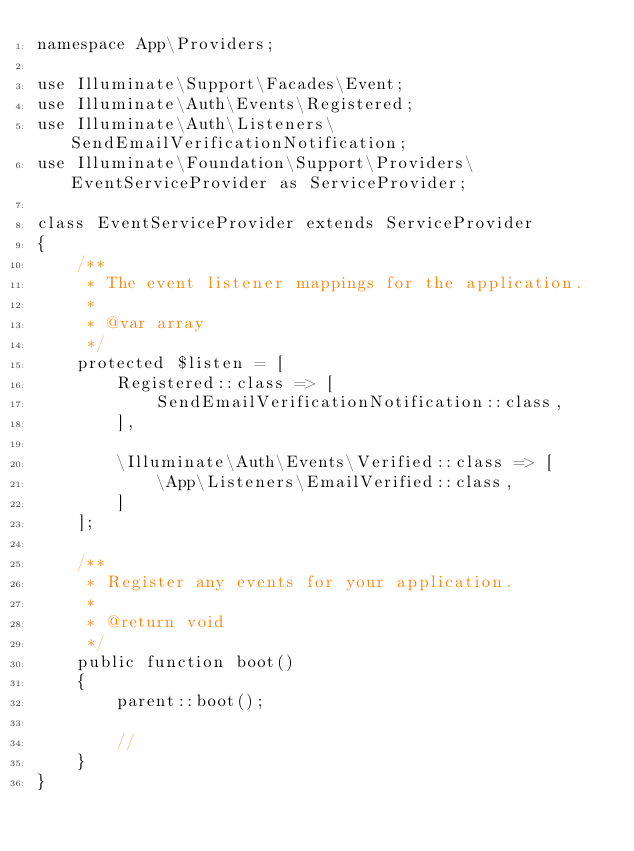Convert code to text. <code><loc_0><loc_0><loc_500><loc_500><_PHP_>namespace App\Providers;

use Illuminate\Support\Facades\Event;
use Illuminate\Auth\Events\Registered;
use Illuminate\Auth\Listeners\SendEmailVerificationNotification;
use Illuminate\Foundation\Support\Providers\EventServiceProvider as ServiceProvider;

class EventServiceProvider extends ServiceProvider
{
    /**
     * The event listener mappings for the application.
     *
     * @var array
     */
    protected $listen = [
        Registered::class => [
            SendEmailVerificationNotification::class,
        ],

        \Illuminate\Auth\Events\Verified::class => [
            \App\Listeners\EmailVerified::class,
        ]
    ];

    /**
     * Register any events for your application.
     *
     * @return void
     */
    public function boot()
    {
        parent::boot();

        //
    }
}
</code> 